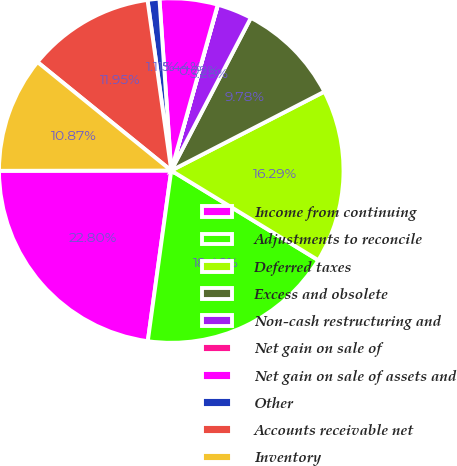<chart> <loc_0><loc_0><loc_500><loc_500><pie_chart><fcel>Income from continuing<fcel>Adjustments to reconcile<fcel>Deferred taxes<fcel>Excess and obsolete<fcel>Non-cash restructuring and<fcel>Net gain on sale of<fcel>Net gain on sale of assets and<fcel>Other<fcel>Accounts receivable net<fcel>Inventory<nl><fcel>22.8%<fcel>18.46%<fcel>16.29%<fcel>9.78%<fcel>3.28%<fcel>0.02%<fcel>5.44%<fcel>1.11%<fcel>11.95%<fcel>10.87%<nl></chart> 